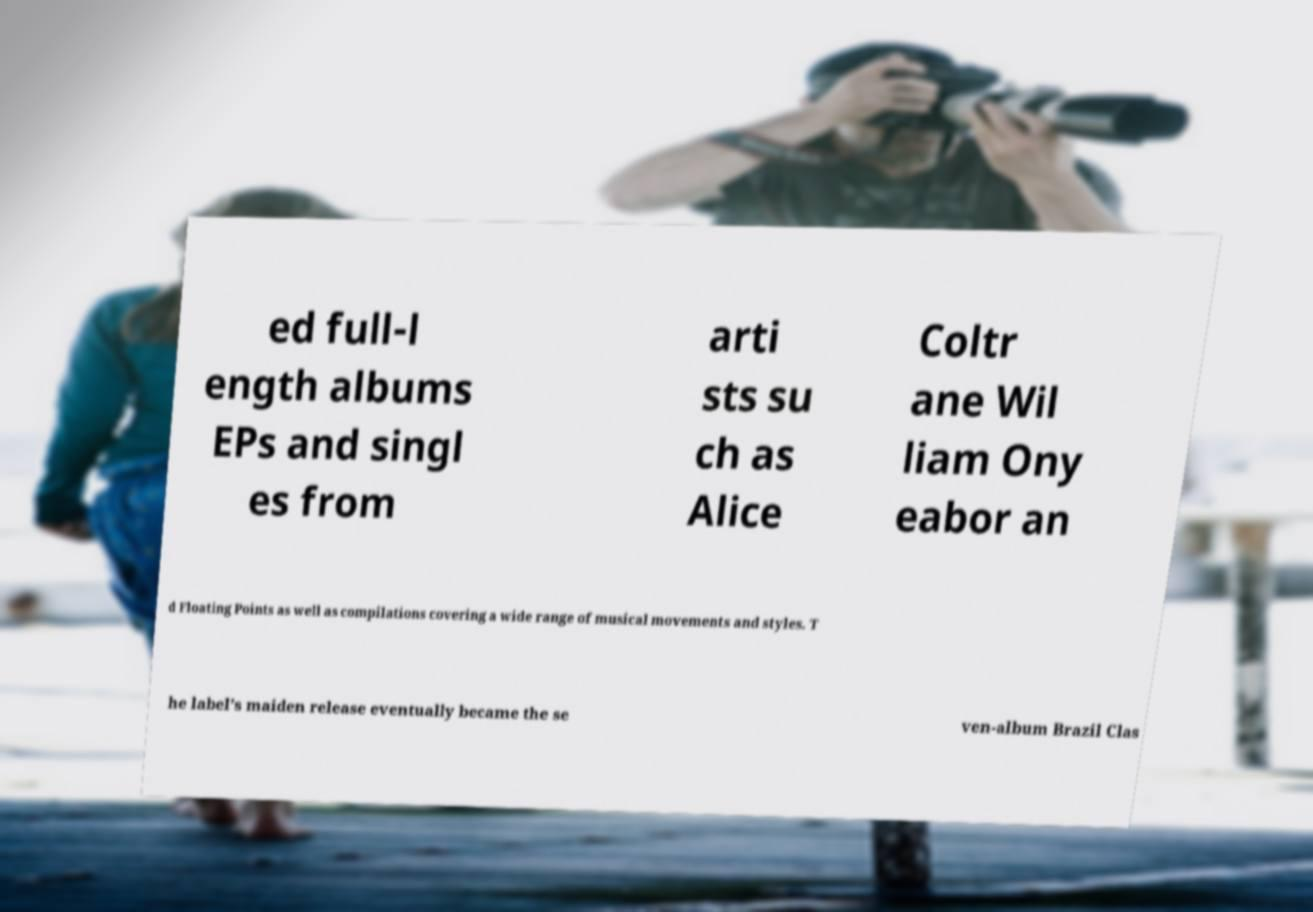I need the written content from this picture converted into text. Can you do that? ed full-l ength albums EPs and singl es from arti sts su ch as Alice Coltr ane Wil liam Ony eabor an d Floating Points as well as compilations covering a wide range of musical movements and styles. T he label’s maiden release eventually became the se ven-album Brazil Clas 